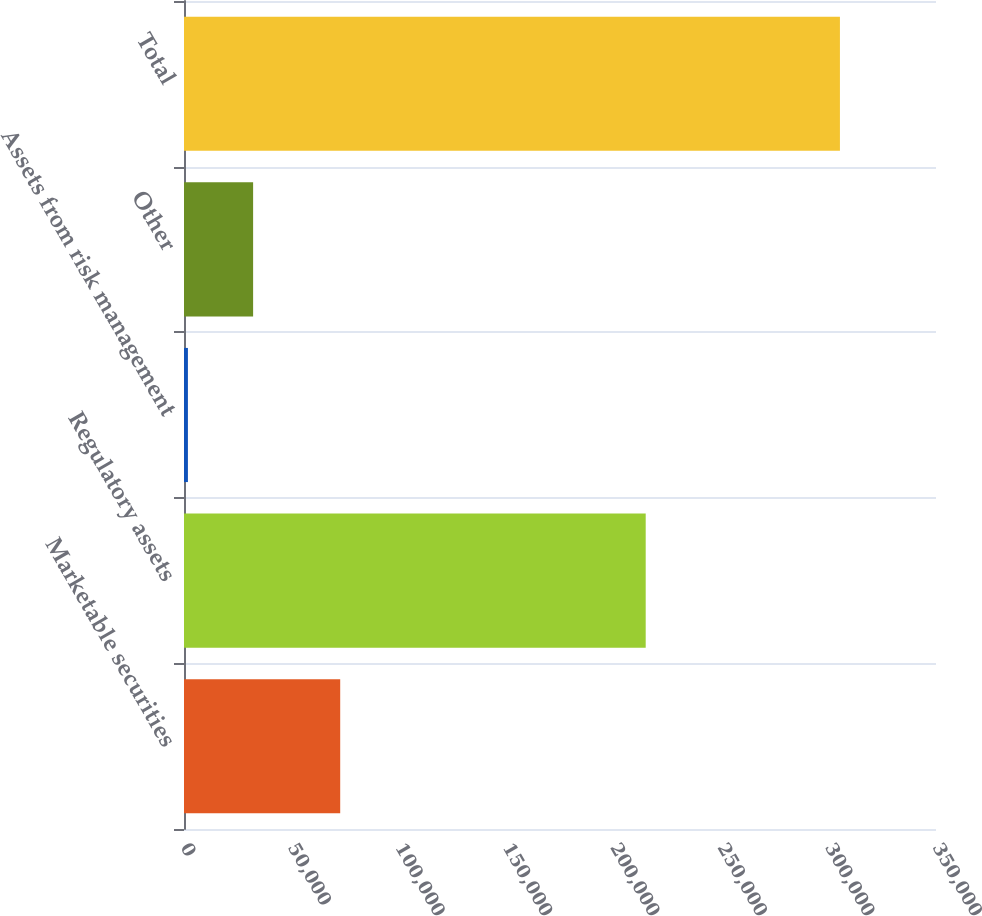Convert chart to OTSL. <chart><loc_0><loc_0><loc_500><loc_500><bar_chart><fcel>Marketable securities<fcel>Regulatory assets<fcel>Assets from risk management<fcel>Other<fcel>Total<nl><fcel>72701<fcel>214890<fcel>1822<fcel>32168.3<fcel>305285<nl></chart> 